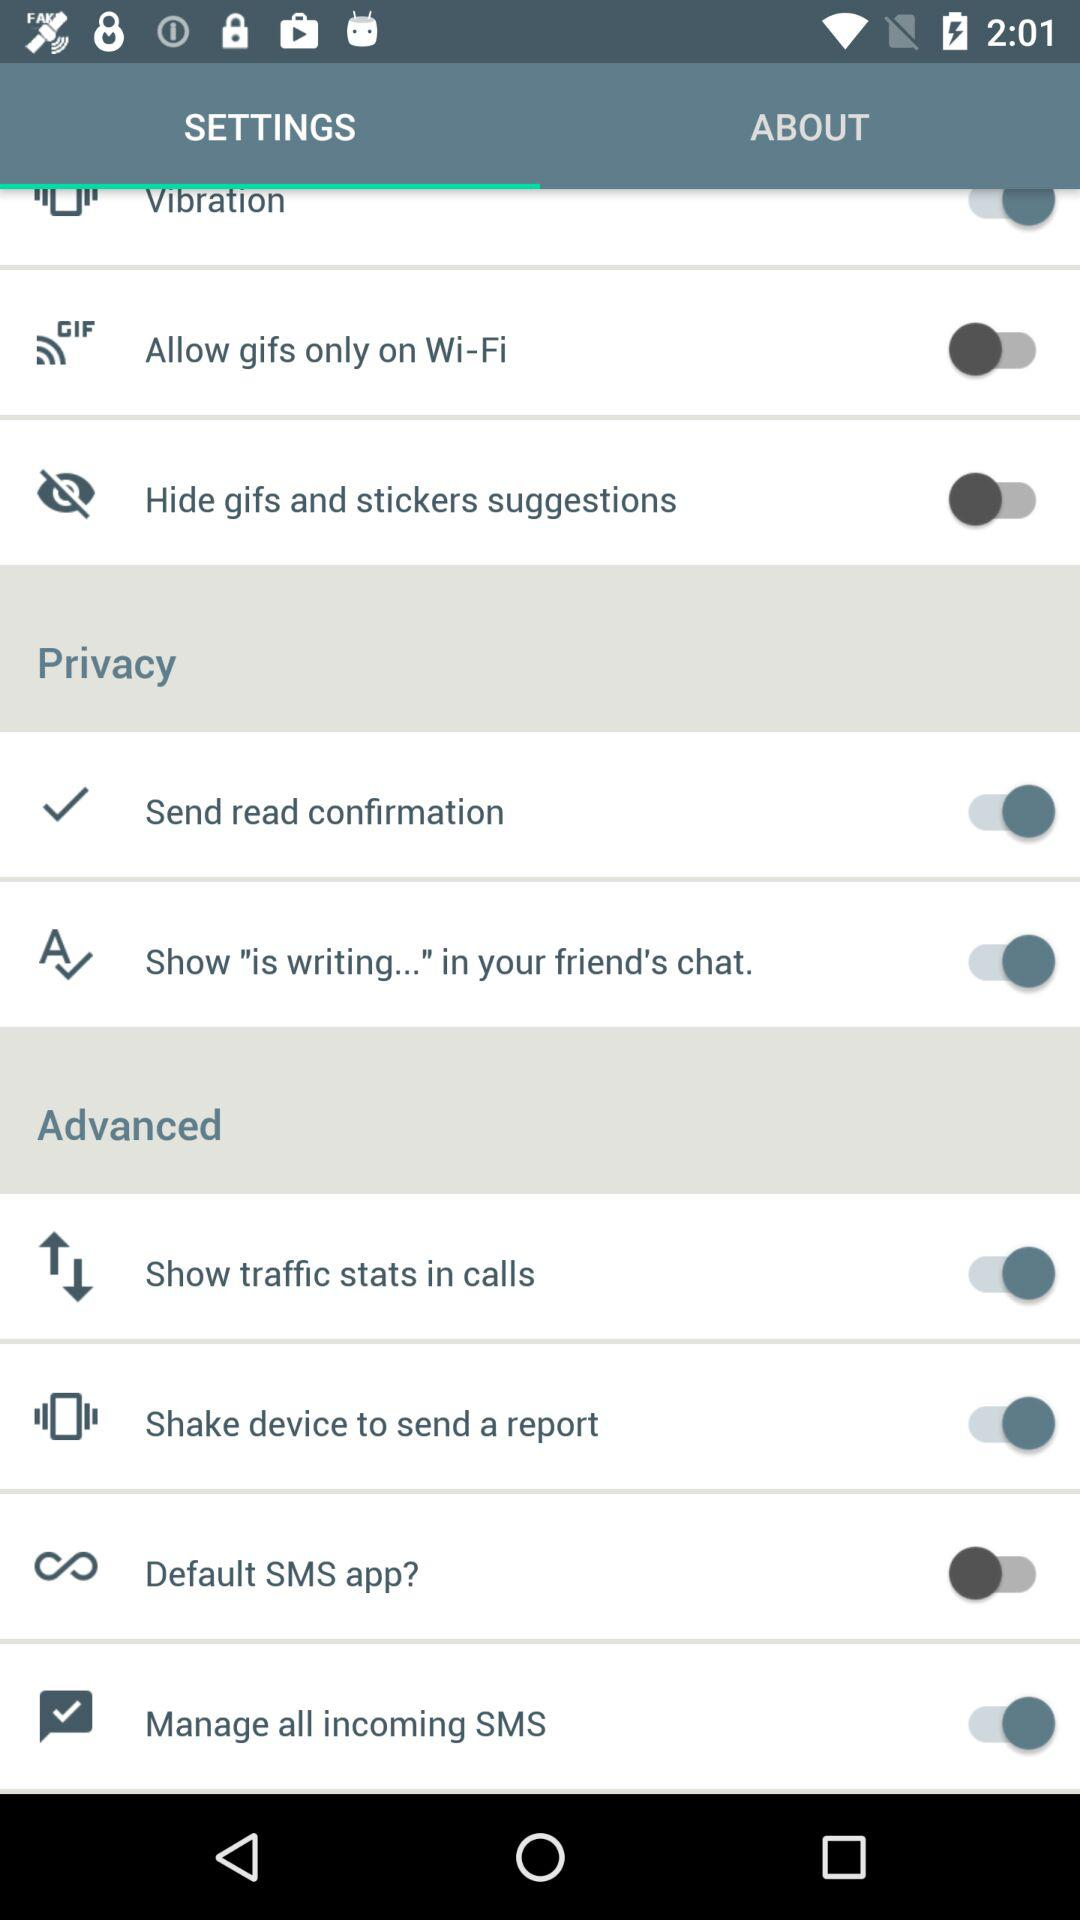Which tab is selected? The selected tab is "SETTINGS". 